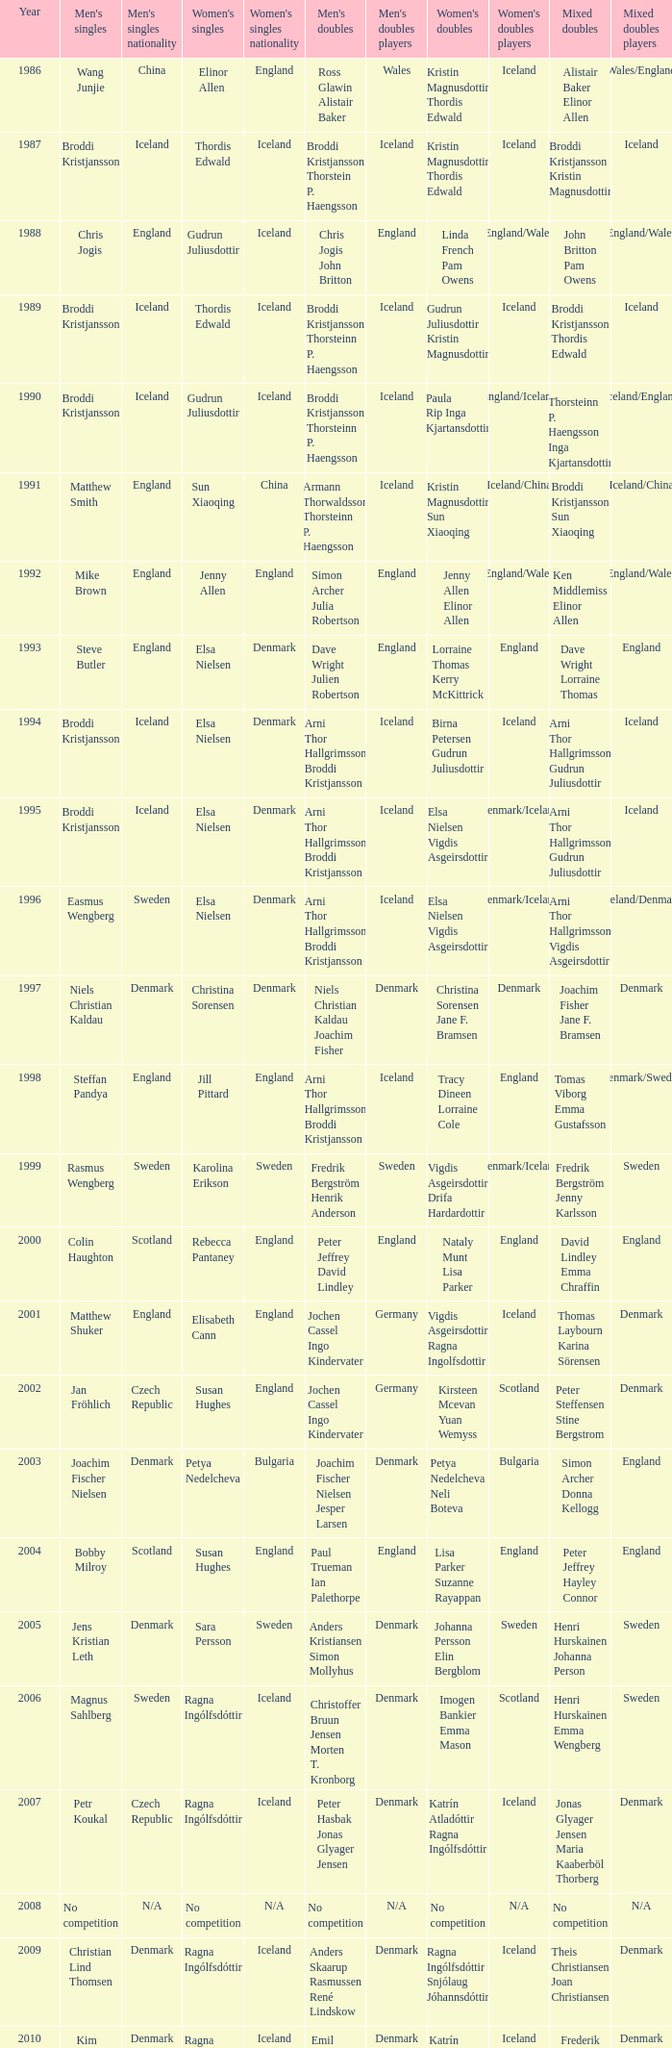Which mixed doubles happened later than 2011? Chou Tien-chen Chiang Mei-hui. 